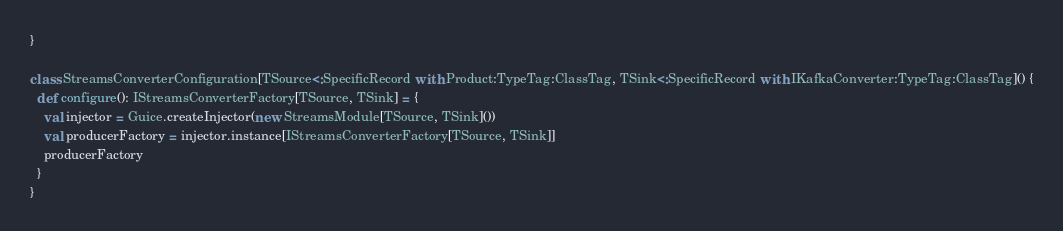<code> <loc_0><loc_0><loc_500><loc_500><_Scala_>}

class StreamsConverterConfiguration[TSource<:SpecificRecord with Product:TypeTag:ClassTag, TSink<:SpecificRecord with IKafkaConverter:TypeTag:ClassTag]() {
  def configure(): IStreamsConverterFactory[TSource, TSink] = {
    val injector = Guice.createInjector(new StreamsModule[TSource, TSink]())
    val producerFactory = injector.instance[IStreamsConverterFactory[TSource, TSink]]
    producerFactory
  }
}
</code> 